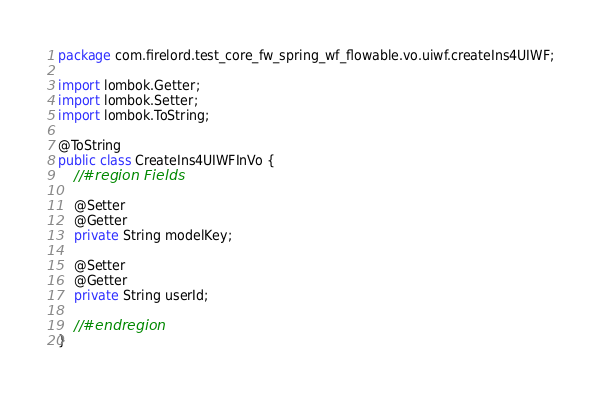<code> <loc_0><loc_0><loc_500><loc_500><_Java_>package com.firelord.test_core_fw_spring_wf_flowable.vo.uiwf.createIns4UIWF;

import lombok.Getter;
import lombok.Setter;
import lombok.ToString;

@ToString
public class CreateIns4UIWFInVo {
    //#region Fields

    @Setter
    @Getter
    private String modelKey;

    @Setter
    @Getter
    private String userId;

    //#endregion
}
</code> 